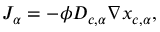Convert formula to latex. <formula><loc_0><loc_0><loc_500><loc_500>J _ { \alpha } = - \phi D _ { c , \alpha } \nabla x _ { c , \alpha } ,</formula> 